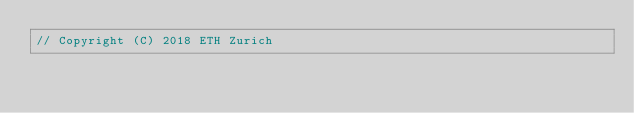<code> <loc_0><loc_0><loc_500><loc_500><_C++_>// Copyright (C) 2018 ETH Zurich</code> 